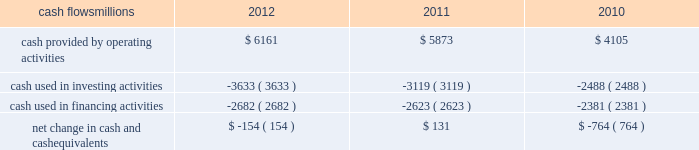At december 31 , 2012 and 2011 , we had a working capital surplus .
This reflects a strong cash position , which provides enhanced liquidity in an uncertain economic environment .
In addition , we believe we have adequate access to capital markets to meet any foreseeable cash requirements , and we have sufficient financial capacity to satisfy our current liabilities .
Cash flows millions 2012 2011 2010 .
Operating activities higher net income in 2012 increased cash provided by operating activities compared to 2011 , partially offset by lower tax benefits from bonus depreciation ( as explained below ) and payments for past wages based on national labor negotiations settled earlier this year .
Higher net income and lower cash income tax payments in 2011 increased cash provided by operating activities compared to 2010 .
The tax relief , unemployment insurance reauthorization , and job creation act of 2010 provided for 100% ( 100 % ) bonus depreciation for qualified investments made during 2011 , and 50% ( 50 % ) bonus depreciation for qualified investments made during 2012 .
As a result of the act , the company deferred a substantial portion of its 2011 income tax expense .
This deferral decreased 2011 income tax payments , thereby contributing to the positive operating cash flow .
In future years , however , additional cash will be used to pay income taxes that were previously deferred .
In addition , the adoption of a new accounting standard in january of 2010 changed the accounting treatment for our receivables securitization facility from a sale of undivided interests ( recorded as an operating activity ) to a secured borrowing ( recorded as a financing activity ) , which decreased cash provided by operating activities by $ 400 million in 2010 .
Investing activities higher capital investments in 2012 drove the increase in cash used in investing activities compared to 2011 .
Included in capital investments in 2012 was $ 75 million for the early buyout of 165 locomotives under long-term operating and capital leases during the first quarter of 2012 , which we exercised due to favorable economic terms and market conditions .
Higher capital investments partially offset by higher proceeds from asset sales in 2011 drove the increase in cash used in investing activities compared to 2010. .
What was the change in millions of cash provided by operating activities from 2011 to 2012? 
Computations: (6161 - 5873)
Answer: 288.0. 